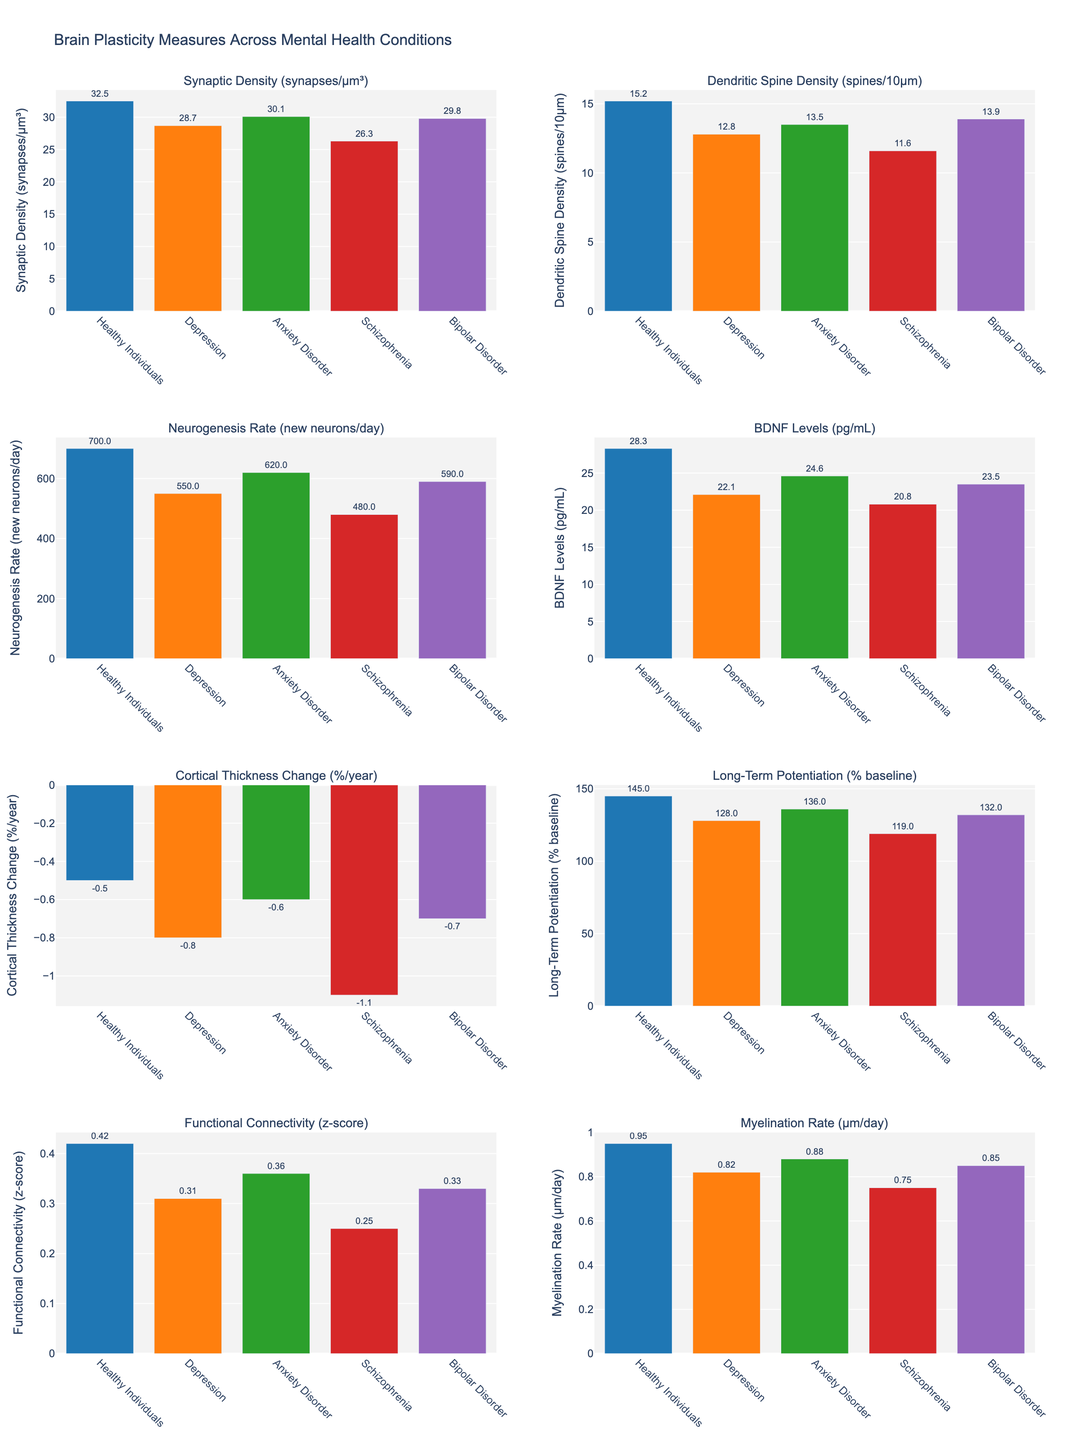Which mental health condition has the lowest Neurogenesis Rate (new neurons/day)? Observe the bar heights for the Neurogenesis Rate subplot; the bar for Schizophrenia is visibly the shortest, indicating the lowest rate.
Answer: Schizophrenia How does Synaptic Density (synapses/μm³) in Depressed individuals compare with Healthy Individuals? Look at the Synaptic Density subplot. The bar for Depressed individuals is shorter than the one for Healthy Individuals, which indicates a lower synaptic density in Depressed individuals.
Answer: Lower What is the average functional connectivity z-score across all mental health conditions? Add the Functional Connectivity (z-score) values for each condition (0.31 for Depression, 0.36 for Anxiety Disorder, 0.25 for Schizophrenia, and 0.33 for Bipolar Disorder), then divide by 4: (0.31 + 0.36 + 0.25 + 0.33) / 4 = 0.3125.
Answer: 0.3125 Which brain plasticity measure shows the smallest change between Healthy Individuals and Bipolar Disorder? Compare the differences across all subplots: Functional Connectivity changes from 0.42 to 0.33 for Bipolar Disorder, which is the smallest absolute change (0.09).
Answer: Functional Connectivity In which mental health disorder do BDNF Levels (pg/mL) decrease the most compared to Healthy Individuals? Calculate the difference for each condition: Depression (28.3 - 22.1 = 6.2), Anxiety (28.3 - 24.6 = 3.7), Schizophrenia (28.3 - 20.8 = 7.5), Bipolar Disorder (28.3 - 23.5 = 4.8). Schizophrenia has the highest decrease.
Answer: Schizophrenia Compare Myelination Rate (μm/day) in Anxiety Disorder and Bipolar Disorder. Which is higher, and by how much? Look at Myelination Rate; Anxiety Disorder shows 0.88 and Bipolar Disorder shows 0.85. The difference is 0.88 - 0.85 = 0.03, so Anxiety Disorder is higher by 0.03.
Answer: Anxiety Disorder, by 0.03 Which mental health disorder has the second lowest Synaptic Density (synapses/µm³)? From the Synaptic Density subplot, Depression (28.7), Anxiety (30.1), Schizophrenia (26.3), Bipolar Disorder (29.8). The second lowest is Bipolar Disorder with 29.8.
Answer: Bipolar Disorder What is the sum of Neurogenesis Rate for Schizophrenia and Anxiety Disorder? Add the Neurogenesis Rate values for Schizophrenia (480) and Anxiety Disorder (620): 480 + 620 = 1100.
Answer: 1100 Identify the measure where Schizophrenia individuals show the greatest deficit compared to Healthy Individuals. Calculate the differences across all measures: Synaptic Density (32.5 - 26.3 = 6.2), Dendritic Spine Density (15.2 - 11.6 = 3.6), Neurogenesis Rate (700 - 480 = 220), BDNF Levels (28.3 - 20.8 = 7.5), Cortical Thickness Change (-0.5 - (-1.1) = 0.6), Long-Term Potentiation (145 - 119 = 26), Functional Connectivity (0.42 - 0.25 = 0.17), Myelination Rate (0.95 - 0.75 = 0.2). Neurogenesis Rate has the greatest difference.
Answer: Neurogenesis Rate By how much does the Long-Term Potentiation (% baseline) change from Healthy Individuals to Anxiety Disorder? Long-Term Potentiation is 145 for Healthy Individuals and 136 for Anxiety Disorder. The change is 145 - 136 = 9.
Answer: Decreases by 9 